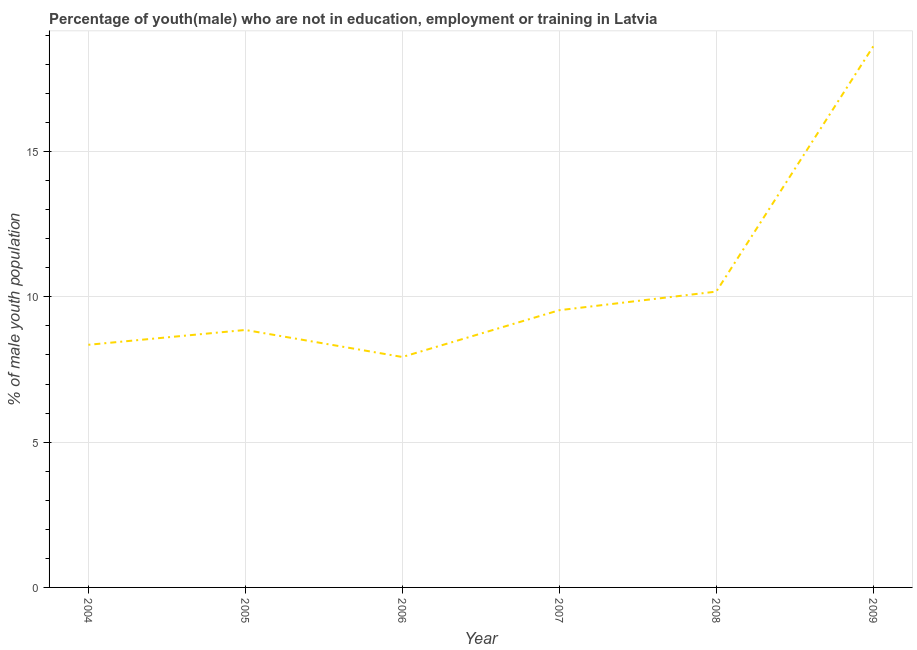What is the unemployed male youth population in 2007?
Provide a short and direct response. 9.54. Across all years, what is the maximum unemployed male youth population?
Your answer should be compact. 18.62. Across all years, what is the minimum unemployed male youth population?
Provide a short and direct response. 7.93. In which year was the unemployed male youth population maximum?
Ensure brevity in your answer.  2009. In which year was the unemployed male youth population minimum?
Offer a very short reply. 2006. What is the sum of the unemployed male youth population?
Provide a succinct answer. 63.48. What is the difference between the unemployed male youth population in 2006 and 2009?
Offer a very short reply. -10.69. What is the average unemployed male youth population per year?
Ensure brevity in your answer.  10.58. What is the median unemployed male youth population?
Keep it short and to the point. 9.2. In how many years, is the unemployed male youth population greater than 14 %?
Your answer should be compact. 1. Do a majority of the years between 2007 and 2008 (inclusive) have unemployed male youth population greater than 9 %?
Your answer should be very brief. Yes. What is the ratio of the unemployed male youth population in 2008 to that in 2009?
Ensure brevity in your answer.  0.55. Is the unemployed male youth population in 2004 less than that in 2009?
Offer a terse response. Yes. What is the difference between the highest and the second highest unemployed male youth population?
Provide a succinct answer. 8.44. Is the sum of the unemployed male youth population in 2005 and 2007 greater than the maximum unemployed male youth population across all years?
Your answer should be compact. No. What is the difference between the highest and the lowest unemployed male youth population?
Make the answer very short. 10.69. In how many years, is the unemployed male youth population greater than the average unemployed male youth population taken over all years?
Provide a short and direct response. 1. Does the unemployed male youth population monotonically increase over the years?
Make the answer very short. No. How many lines are there?
Your answer should be very brief. 1. How many years are there in the graph?
Make the answer very short. 6. What is the difference between two consecutive major ticks on the Y-axis?
Your answer should be very brief. 5. What is the title of the graph?
Your response must be concise. Percentage of youth(male) who are not in education, employment or training in Latvia. What is the label or title of the Y-axis?
Offer a very short reply. % of male youth population. What is the % of male youth population in 2004?
Provide a short and direct response. 8.35. What is the % of male youth population in 2005?
Make the answer very short. 8.86. What is the % of male youth population of 2006?
Keep it short and to the point. 7.93. What is the % of male youth population in 2007?
Your response must be concise. 9.54. What is the % of male youth population of 2008?
Make the answer very short. 10.18. What is the % of male youth population of 2009?
Offer a very short reply. 18.62. What is the difference between the % of male youth population in 2004 and 2005?
Provide a short and direct response. -0.51. What is the difference between the % of male youth population in 2004 and 2006?
Give a very brief answer. 0.42. What is the difference between the % of male youth population in 2004 and 2007?
Make the answer very short. -1.19. What is the difference between the % of male youth population in 2004 and 2008?
Give a very brief answer. -1.83. What is the difference between the % of male youth population in 2004 and 2009?
Offer a very short reply. -10.27. What is the difference between the % of male youth population in 2005 and 2007?
Give a very brief answer. -0.68. What is the difference between the % of male youth population in 2005 and 2008?
Provide a succinct answer. -1.32. What is the difference between the % of male youth population in 2005 and 2009?
Your response must be concise. -9.76. What is the difference between the % of male youth population in 2006 and 2007?
Your response must be concise. -1.61. What is the difference between the % of male youth population in 2006 and 2008?
Give a very brief answer. -2.25. What is the difference between the % of male youth population in 2006 and 2009?
Provide a succinct answer. -10.69. What is the difference between the % of male youth population in 2007 and 2008?
Keep it short and to the point. -0.64. What is the difference between the % of male youth population in 2007 and 2009?
Give a very brief answer. -9.08. What is the difference between the % of male youth population in 2008 and 2009?
Your answer should be very brief. -8.44. What is the ratio of the % of male youth population in 2004 to that in 2005?
Your answer should be compact. 0.94. What is the ratio of the % of male youth population in 2004 to that in 2006?
Your answer should be compact. 1.05. What is the ratio of the % of male youth population in 2004 to that in 2007?
Offer a very short reply. 0.88. What is the ratio of the % of male youth population in 2004 to that in 2008?
Your response must be concise. 0.82. What is the ratio of the % of male youth population in 2004 to that in 2009?
Keep it short and to the point. 0.45. What is the ratio of the % of male youth population in 2005 to that in 2006?
Keep it short and to the point. 1.12. What is the ratio of the % of male youth population in 2005 to that in 2007?
Provide a succinct answer. 0.93. What is the ratio of the % of male youth population in 2005 to that in 2008?
Offer a very short reply. 0.87. What is the ratio of the % of male youth population in 2005 to that in 2009?
Ensure brevity in your answer.  0.48. What is the ratio of the % of male youth population in 2006 to that in 2007?
Make the answer very short. 0.83. What is the ratio of the % of male youth population in 2006 to that in 2008?
Make the answer very short. 0.78. What is the ratio of the % of male youth population in 2006 to that in 2009?
Your response must be concise. 0.43. What is the ratio of the % of male youth population in 2007 to that in 2008?
Keep it short and to the point. 0.94. What is the ratio of the % of male youth population in 2007 to that in 2009?
Ensure brevity in your answer.  0.51. What is the ratio of the % of male youth population in 2008 to that in 2009?
Your answer should be very brief. 0.55. 